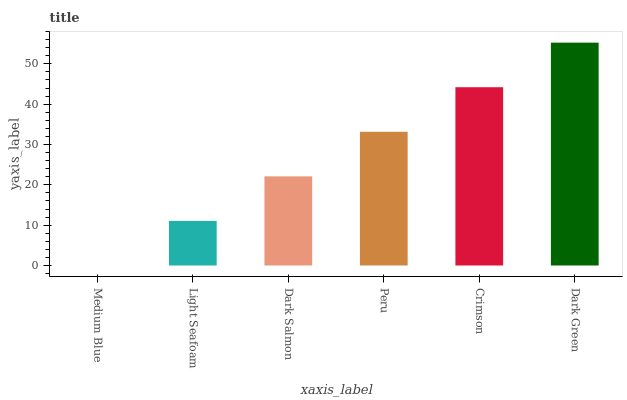Is Light Seafoam the minimum?
Answer yes or no. No. Is Light Seafoam the maximum?
Answer yes or no. No. Is Light Seafoam greater than Medium Blue?
Answer yes or no. Yes. Is Medium Blue less than Light Seafoam?
Answer yes or no. Yes. Is Medium Blue greater than Light Seafoam?
Answer yes or no. No. Is Light Seafoam less than Medium Blue?
Answer yes or no. No. Is Peru the high median?
Answer yes or no. Yes. Is Dark Salmon the low median?
Answer yes or no. Yes. Is Dark Salmon the high median?
Answer yes or no. No. Is Medium Blue the low median?
Answer yes or no. No. 